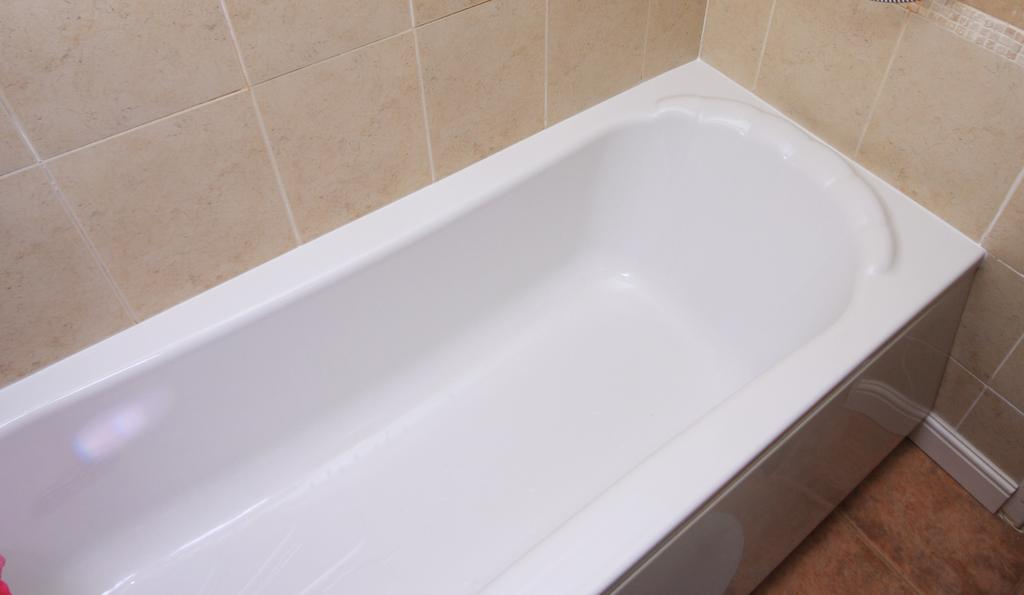What is the main object in the center of the image? There is a bathtub in the center of the image. What can be seen in the background of the image? There is a wall in the background of the image. What type of poison is being used to heat the bathtub in the image? There is no poison or heating element mentioned in the image; it only shows a bathtub and a wall. 